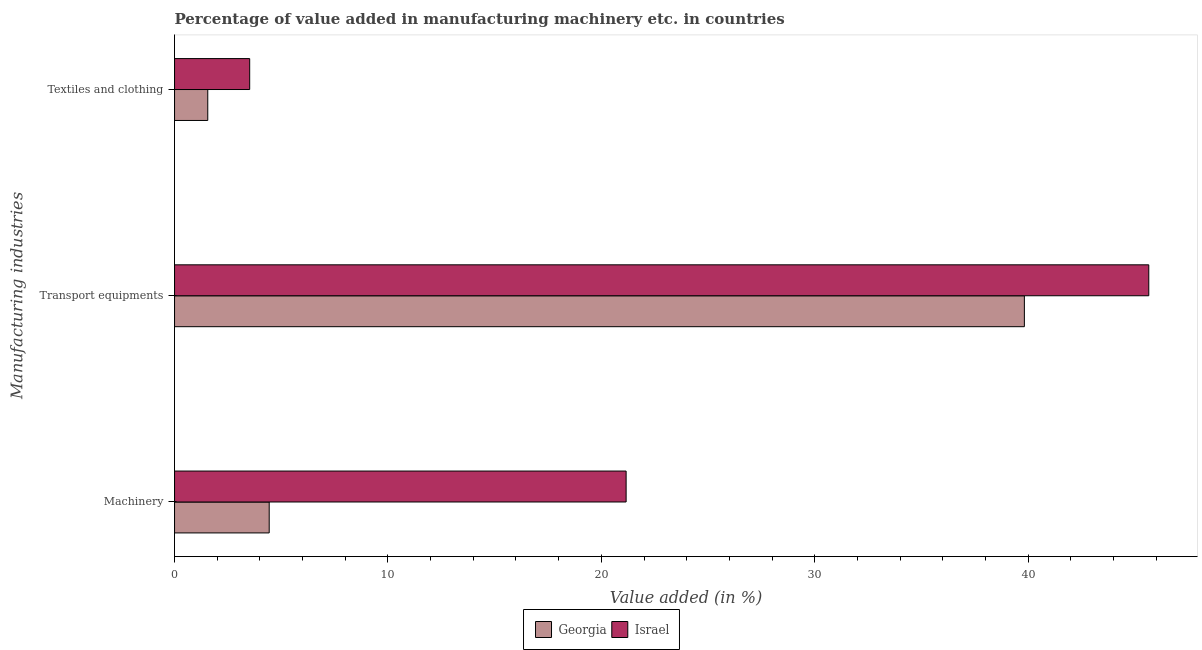Are the number of bars on each tick of the Y-axis equal?
Make the answer very short. Yes. What is the label of the 2nd group of bars from the top?
Keep it short and to the point. Transport equipments. What is the value added in manufacturing textile and clothing in Israel?
Offer a very short reply. 3.52. Across all countries, what is the maximum value added in manufacturing machinery?
Offer a terse response. 21.16. Across all countries, what is the minimum value added in manufacturing textile and clothing?
Your answer should be compact. 1.56. In which country was the value added in manufacturing machinery maximum?
Provide a short and direct response. Israel. In which country was the value added in manufacturing machinery minimum?
Provide a short and direct response. Georgia. What is the total value added in manufacturing textile and clothing in the graph?
Offer a very short reply. 5.08. What is the difference between the value added in manufacturing machinery in Israel and that in Georgia?
Make the answer very short. 16.73. What is the difference between the value added in manufacturing textile and clothing in Israel and the value added in manufacturing transport equipments in Georgia?
Your answer should be compact. -36.3. What is the average value added in manufacturing machinery per country?
Keep it short and to the point. 12.8. What is the difference between the value added in manufacturing transport equipments and value added in manufacturing machinery in Georgia?
Offer a terse response. 35.39. In how many countries, is the value added in manufacturing transport equipments greater than 44 %?
Offer a very short reply. 1. What is the ratio of the value added in manufacturing textile and clothing in Georgia to that in Israel?
Your response must be concise. 0.44. What is the difference between the highest and the second highest value added in manufacturing machinery?
Give a very brief answer. 16.73. What is the difference between the highest and the lowest value added in manufacturing textile and clothing?
Make the answer very short. 1.96. What does the 1st bar from the bottom in Textiles and clothing represents?
Ensure brevity in your answer.  Georgia. Is it the case that in every country, the sum of the value added in manufacturing machinery and value added in manufacturing transport equipments is greater than the value added in manufacturing textile and clothing?
Your answer should be compact. Yes. How many bars are there?
Your answer should be compact. 6. Are all the bars in the graph horizontal?
Your answer should be very brief. Yes. What is the difference between two consecutive major ticks on the X-axis?
Your answer should be compact. 10. Where does the legend appear in the graph?
Offer a terse response. Bottom center. How many legend labels are there?
Offer a terse response. 2. What is the title of the graph?
Your answer should be compact. Percentage of value added in manufacturing machinery etc. in countries. Does "Dominica" appear as one of the legend labels in the graph?
Provide a succinct answer. No. What is the label or title of the X-axis?
Give a very brief answer. Value added (in %). What is the label or title of the Y-axis?
Make the answer very short. Manufacturing industries. What is the Value added (in %) in Georgia in Machinery?
Make the answer very short. 4.44. What is the Value added (in %) in Israel in Machinery?
Make the answer very short. 21.16. What is the Value added (in %) of Georgia in Transport equipments?
Offer a very short reply. 39.82. What is the Value added (in %) of Israel in Transport equipments?
Give a very brief answer. 45.65. What is the Value added (in %) in Georgia in Textiles and clothing?
Offer a terse response. 1.56. What is the Value added (in %) in Israel in Textiles and clothing?
Give a very brief answer. 3.52. Across all Manufacturing industries, what is the maximum Value added (in %) in Georgia?
Provide a succinct answer. 39.82. Across all Manufacturing industries, what is the maximum Value added (in %) of Israel?
Keep it short and to the point. 45.65. Across all Manufacturing industries, what is the minimum Value added (in %) of Georgia?
Ensure brevity in your answer.  1.56. Across all Manufacturing industries, what is the minimum Value added (in %) in Israel?
Make the answer very short. 3.52. What is the total Value added (in %) of Georgia in the graph?
Offer a very short reply. 45.82. What is the total Value added (in %) in Israel in the graph?
Your answer should be compact. 70.34. What is the difference between the Value added (in %) of Georgia in Machinery and that in Transport equipments?
Keep it short and to the point. -35.39. What is the difference between the Value added (in %) of Israel in Machinery and that in Transport equipments?
Make the answer very short. -24.49. What is the difference between the Value added (in %) in Georgia in Machinery and that in Textiles and clothing?
Your answer should be compact. 2.88. What is the difference between the Value added (in %) of Israel in Machinery and that in Textiles and clothing?
Make the answer very short. 17.64. What is the difference between the Value added (in %) in Georgia in Transport equipments and that in Textiles and clothing?
Ensure brevity in your answer.  38.27. What is the difference between the Value added (in %) in Israel in Transport equipments and that in Textiles and clothing?
Ensure brevity in your answer.  42.13. What is the difference between the Value added (in %) of Georgia in Machinery and the Value added (in %) of Israel in Transport equipments?
Your answer should be very brief. -41.22. What is the difference between the Value added (in %) of Georgia in Machinery and the Value added (in %) of Israel in Textiles and clothing?
Your answer should be compact. 0.91. What is the difference between the Value added (in %) of Georgia in Transport equipments and the Value added (in %) of Israel in Textiles and clothing?
Offer a terse response. 36.3. What is the average Value added (in %) in Georgia per Manufacturing industries?
Give a very brief answer. 15.27. What is the average Value added (in %) of Israel per Manufacturing industries?
Provide a short and direct response. 23.45. What is the difference between the Value added (in %) of Georgia and Value added (in %) of Israel in Machinery?
Ensure brevity in your answer.  -16.73. What is the difference between the Value added (in %) in Georgia and Value added (in %) in Israel in Transport equipments?
Offer a terse response. -5.83. What is the difference between the Value added (in %) in Georgia and Value added (in %) in Israel in Textiles and clothing?
Offer a terse response. -1.96. What is the ratio of the Value added (in %) in Georgia in Machinery to that in Transport equipments?
Make the answer very short. 0.11. What is the ratio of the Value added (in %) in Israel in Machinery to that in Transport equipments?
Keep it short and to the point. 0.46. What is the ratio of the Value added (in %) in Georgia in Machinery to that in Textiles and clothing?
Your response must be concise. 2.85. What is the ratio of the Value added (in %) of Israel in Machinery to that in Textiles and clothing?
Your response must be concise. 6.01. What is the ratio of the Value added (in %) of Georgia in Transport equipments to that in Textiles and clothing?
Your answer should be very brief. 25.58. What is the ratio of the Value added (in %) of Israel in Transport equipments to that in Textiles and clothing?
Your answer should be compact. 12.97. What is the difference between the highest and the second highest Value added (in %) in Georgia?
Keep it short and to the point. 35.39. What is the difference between the highest and the second highest Value added (in %) of Israel?
Your response must be concise. 24.49. What is the difference between the highest and the lowest Value added (in %) of Georgia?
Your response must be concise. 38.27. What is the difference between the highest and the lowest Value added (in %) in Israel?
Your response must be concise. 42.13. 